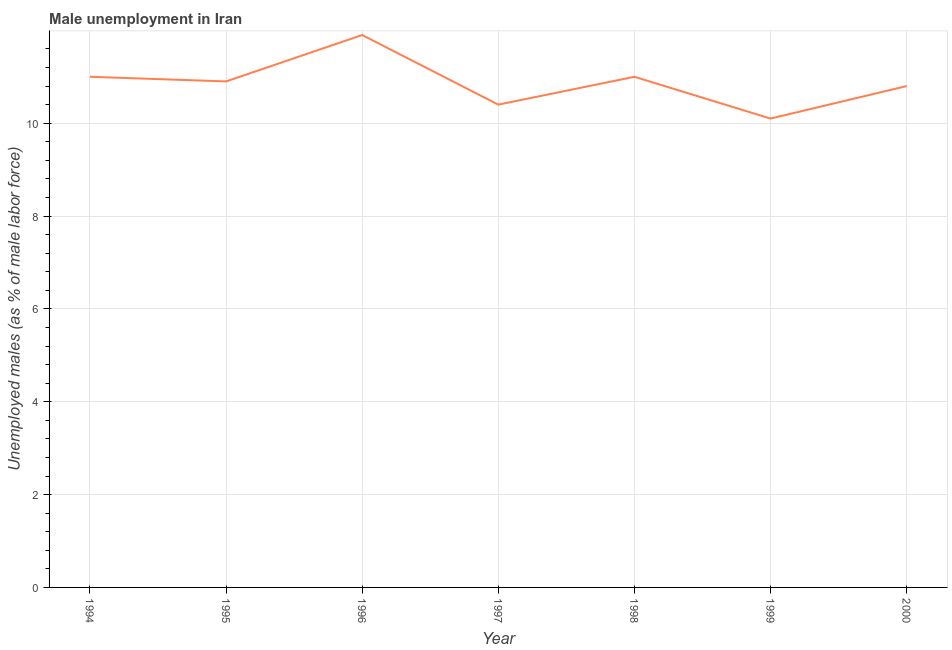What is the unemployed males population in 1999?
Your answer should be very brief. 10.1. Across all years, what is the maximum unemployed males population?
Make the answer very short. 11.9. Across all years, what is the minimum unemployed males population?
Offer a very short reply. 10.1. In which year was the unemployed males population maximum?
Make the answer very short. 1996. In which year was the unemployed males population minimum?
Ensure brevity in your answer.  1999. What is the sum of the unemployed males population?
Make the answer very short. 76.1. What is the difference between the unemployed males population in 1994 and 2000?
Your answer should be very brief. 0.2. What is the average unemployed males population per year?
Provide a short and direct response. 10.87. What is the median unemployed males population?
Offer a terse response. 10.9. Do a majority of the years between 1998 and 1999 (inclusive) have unemployed males population greater than 6.4 %?
Your response must be concise. Yes. What is the ratio of the unemployed males population in 1999 to that in 2000?
Ensure brevity in your answer.  0.94. What is the difference between the highest and the second highest unemployed males population?
Your answer should be compact. 0.9. What is the difference between the highest and the lowest unemployed males population?
Make the answer very short. 1.8. Does the unemployed males population monotonically increase over the years?
Keep it short and to the point. No. How many years are there in the graph?
Make the answer very short. 7. Are the values on the major ticks of Y-axis written in scientific E-notation?
Offer a very short reply. No. What is the title of the graph?
Ensure brevity in your answer.  Male unemployment in Iran. What is the label or title of the Y-axis?
Give a very brief answer. Unemployed males (as % of male labor force). What is the Unemployed males (as % of male labor force) in 1994?
Offer a very short reply. 11. What is the Unemployed males (as % of male labor force) of 1995?
Your answer should be very brief. 10.9. What is the Unemployed males (as % of male labor force) of 1996?
Your answer should be very brief. 11.9. What is the Unemployed males (as % of male labor force) in 1997?
Give a very brief answer. 10.4. What is the Unemployed males (as % of male labor force) of 1999?
Keep it short and to the point. 10.1. What is the Unemployed males (as % of male labor force) in 2000?
Give a very brief answer. 10.8. What is the difference between the Unemployed males (as % of male labor force) in 1994 and 1995?
Offer a terse response. 0.1. What is the difference between the Unemployed males (as % of male labor force) in 1994 and 1997?
Make the answer very short. 0.6. What is the difference between the Unemployed males (as % of male labor force) in 1994 and 1998?
Make the answer very short. 0. What is the difference between the Unemployed males (as % of male labor force) in 1994 and 2000?
Your answer should be compact. 0.2. What is the difference between the Unemployed males (as % of male labor force) in 1995 and 1996?
Your answer should be very brief. -1. What is the difference between the Unemployed males (as % of male labor force) in 1995 and 1999?
Provide a short and direct response. 0.8. What is the difference between the Unemployed males (as % of male labor force) in 1995 and 2000?
Make the answer very short. 0.1. What is the difference between the Unemployed males (as % of male labor force) in 1996 and 1997?
Offer a terse response. 1.5. What is the difference between the Unemployed males (as % of male labor force) in 1996 and 1998?
Provide a short and direct response. 0.9. What is the difference between the Unemployed males (as % of male labor force) in 1997 and 1999?
Provide a succinct answer. 0.3. What is the difference between the Unemployed males (as % of male labor force) in 1997 and 2000?
Your answer should be compact. -0.4. What is the difference between the Unemployed males (as % of male labor force) in 1998 and 1999?
Your answer should be compact. 0.9. What is the difference between the Unemployed males (as % of male labor force) in 1999 and 2000?
Make the answer very short. -0.7. What is the ratio of the Unemployed males (as % of male labor force) in 1994 to that in 1995?
Your answer should be compact. 1.01. What is the ratio of the Unemployed males (as % of male labor force) in 1994 to that in 1996?
Your response must be concise. 0.92. What is the ratio of the Unemployed males (as % of male labor force) in 1994 to that in 1997?
Make the answer very short. 1.06. What is the ratio of the Unemployed males (as % of male labor force) in 1994 to that in 1998?
Provide a short and direct response. 1. What is the ratio of the Unemployed males (as % of male labor force) in 1994 to that in 1999?
Keep it short and to the point. 1.09. What is the ratio of the Unemployed males (as % of male labor force) in 1995 to that in 1996?
Keep it short and to the point. 0.92. What is the ratio of the Unemployed males (as % of male labor force) in 1995 to that in 1997?
Ensure brevity in your answer.  1.05. What is the ratio of the Unemployed males (as % of male labor force) in 1995 to that in 1998?
Provide a succinct answer. 0.99. What is the ratio of the Unemployed males (as % of male labor force) in 1995 to that in 1999?
Your answer should be very brief. 1.08. What is the ratio of the Unemployed males (as % of male labor force) in 1996 to that in 1997?
Make the answer very short. 1.14. What is the ratio of the Unemployed males (as % of male labor force) in 1996 to that in 1998?
Provide a succinct answer. 1.08. What is the ratio of the Unemployed males (as % of male labor force) in 1996 to that in 1999?
Your answer should be very brief. 1.18. What is the ratio of the Unemployed males (as % of male labor force) in 1996 to that in 2000?
Give a very brief answer. 1.1. What is the ratio of the Unemployed males (as % of male labor force) in 1997 to that in 1998?
Provide a short and direct response. 0.94. What is the ratio of the Unemployed males (as % of male labor force) in 1998 to that in 1999?
Offer a terse response. 1.09. What is the ratio of the Unemployed males (as % of male labor force) in 1998 to that in 2000?
Ensure brevity in your answer.  1.02. What is the ratio of the Unemployed males (as % of male labor force) in 1999 to that in 2000?
Give a very brief answer. 0.94. 